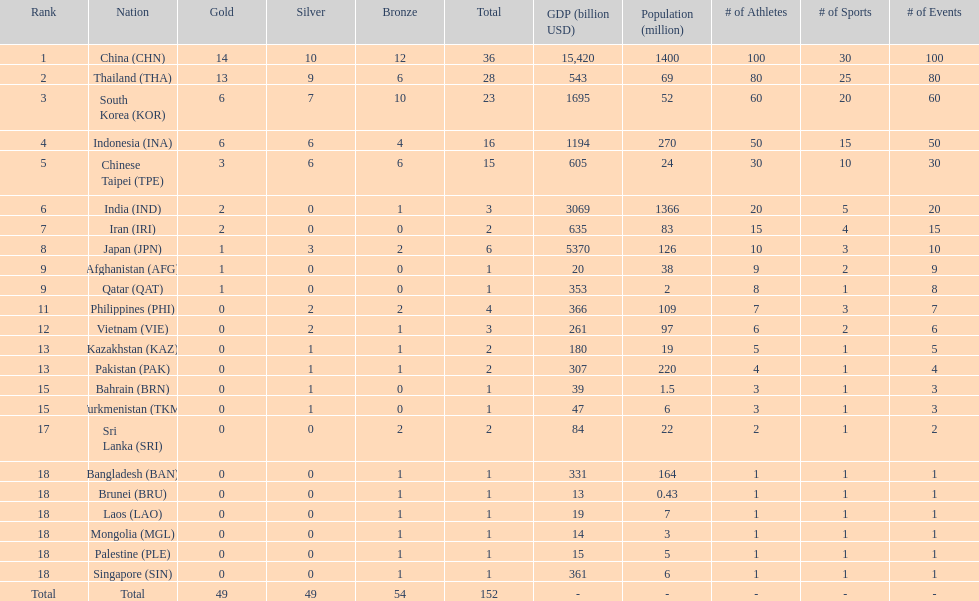How many more medals did india earn compared to pakistan? 1. 